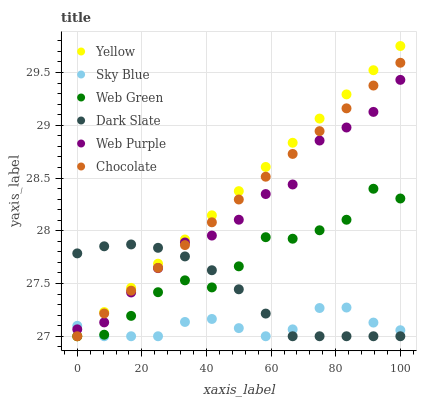Does Sky Blue have the minimum area under the curve?
Answer yes or no. Yes. Does Yellow have the maximum area under the curve?
Answer yes or no. Yes. Does Chocolate have the minimum area under the curve?
Answer yes or no. No. Does Chocolate have the maximum area under the curve?
Answer yes or no. No. Is Chocolate the smoothest?
Answer yes or no. Yes. Is Web Green the roughest?
Answer yes or no. Yes. Is Dark Slate the smoothest?
Answer yes or no. No. Is Dark Slate the roughest?
Answer yes or no. No. Does Web Green have the lowest value?
Answer yes or no. Yes. Does Web Purple have the lowest value?
Answer yes or no. No. Does Yellow have the highest value?
Answer yes or no. Yes. Does Chocolate have the highest value?
Answer yes or no. No. Is Web Green less than Web Purple?
Answer yes or no. Yes. Is Web Purple greater than Web Green?
Answer yes or no. Yes. Does Web Purple intersect Dark Slate?
Answer yes or no. Yes. Is Web Purple less than Dark Slate?
Answer yes or no. No. Is Web Purple greater than Dark Slate?
Answer yes or no. No. Does Web Green intersect Web Purple?
Answer yes or no. No. 